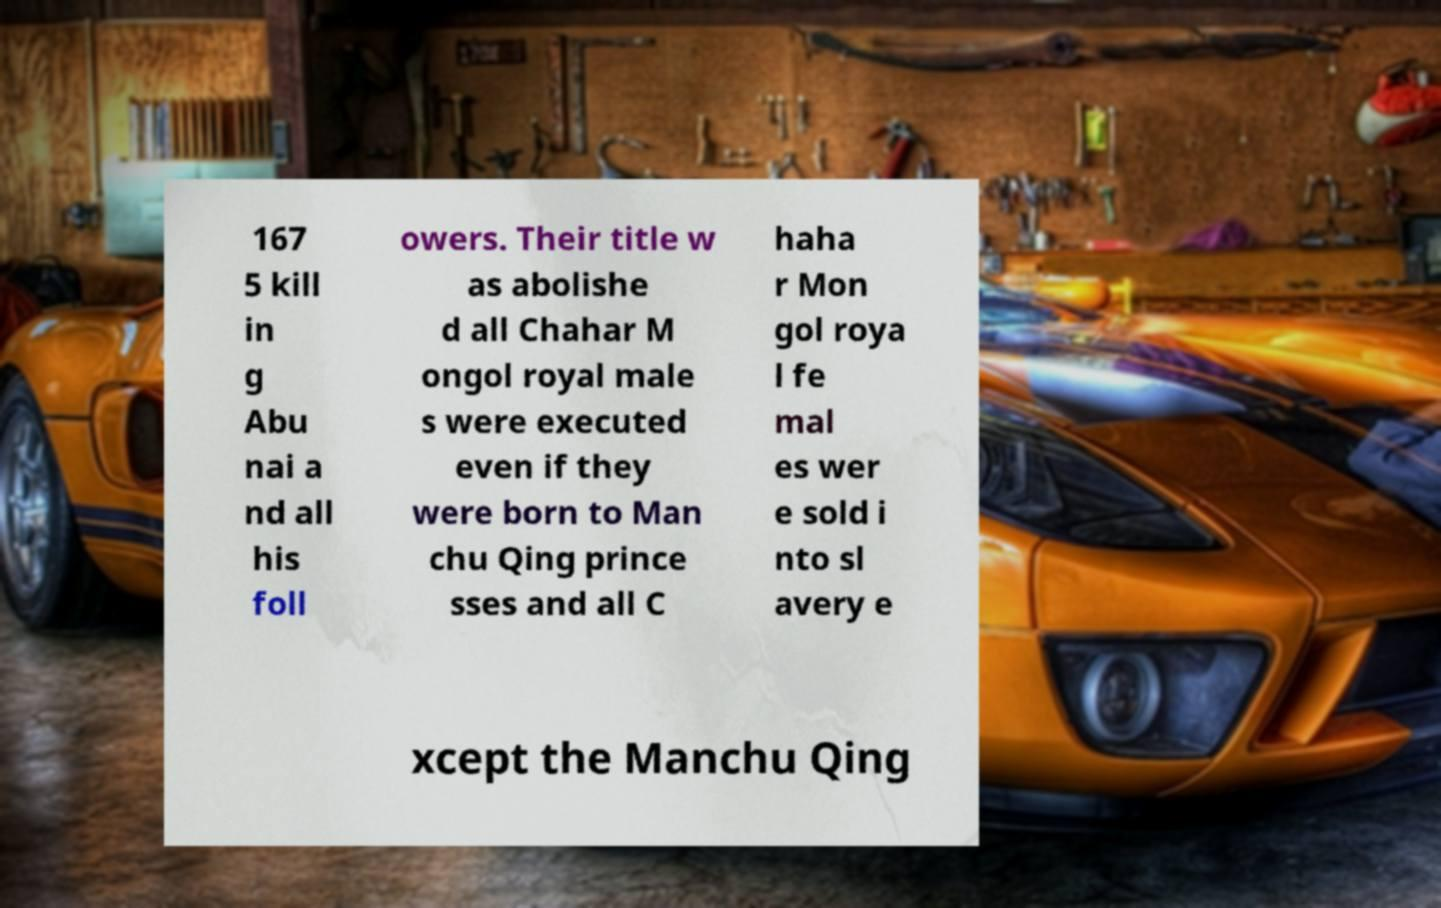Could you assist in decoding the text presented in this image and type it out clearly? 167 5 kill in g Abu nai a nd all his foll owers. Their title w as abolishe d all Chahar M ongol royal male s were executed even if they were born to Man chu Qing prince sses and all C haha r Mon gol roya l fe mal es wer e sold i nto sl avery e xcept the Manchu Qing 